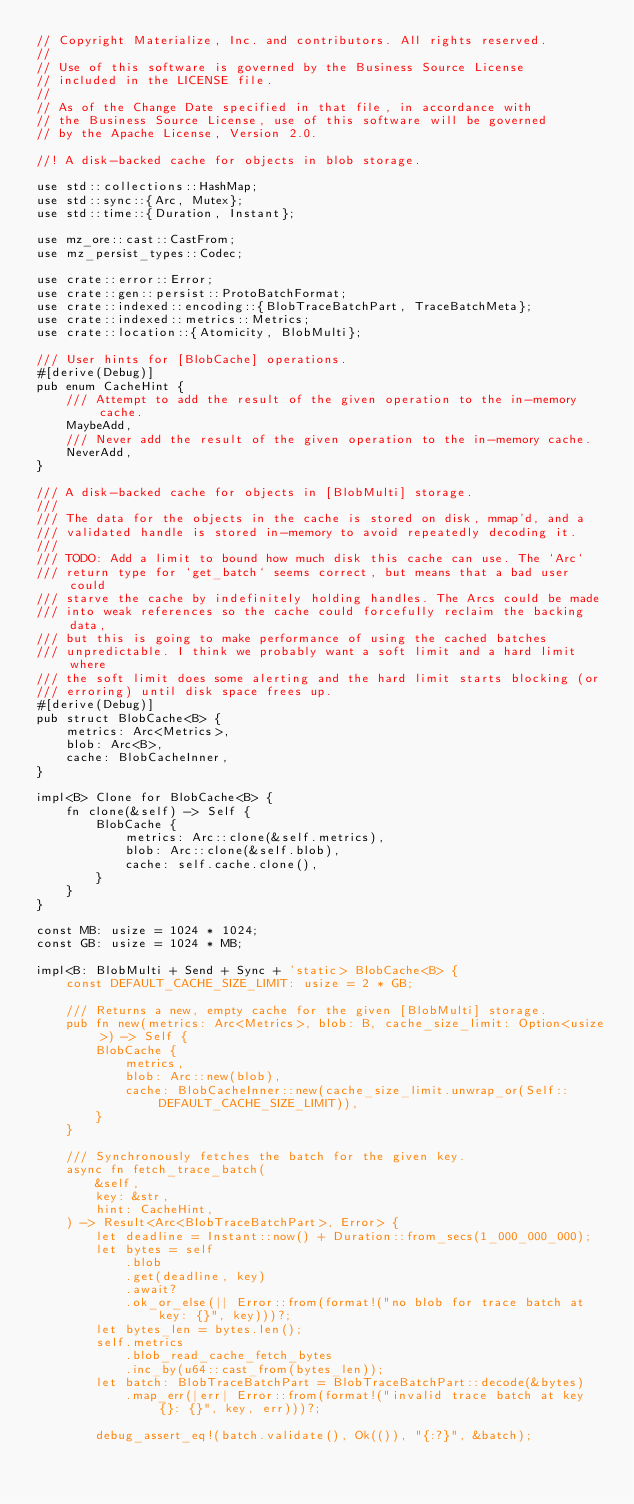Convert code to text. <code><loc_0><loc_0><loc_500><loc_500><_Rust_>// Copyright Materialize, Inc. and contributors. All rights reserved.
//
// Use of this software is governed by the Business Source License
// included in the LICENSE file.
//
// As of the Change Date specified in that file, in accordance with
// the Business Source License, use of this software will be governed
// by the Apache License, Version 2.0.

//! A disk-backed cache for objects in blob storage.

use std::collections::HashMap;
use std::sync::{Arc, Mutex};
use std::time::{Duration, Instant};

use mz_ore::cast::CastFrom;
use mz_persist_types::Codec;

use crate::error::Error;
use crate::gen::persist::ProtoBatchFormat;
use crate::indexed::encoding::{BlobTraceBatchPart, TraceBatchMeta};
use crate::indexed::metrics::Metrics;
use crate::location::{Atomicity, BlobMulti};

/// User hints for [BlobCache] operations.
#[derive(Debug)]
pub enum CacheHint {
    /// Attempt to add the result of the given operation to the in-memory cache.
    MaybeAdd,
    /// Never add the result of the given operation to the in-memory cache.
    NeverAdd,
}

/// A disk-backed cache for objects in [BlobMulti] storage.
///
/// The data for the objects in the cache is stored on disk, mmap'd, and a
/// validated handle is stored in-memory to avoid repeatedly decoding it.
///
/// TODO: Add a limit to bound how much disk this cache can use. The `Arc`
/// return type for `get_batch` seems correct, but means that a bad user could
/// starve the cache by indefinitely holding handles. The Arcs could be made
/// into weak references so the cache could forcefully reclaim the backing data,
/// but this is going to make performance of using the cached batches
/// unpredictable. I think we probably want a soft limit and a hard limit where
/// the soft limit does some alerting and the hard limit starts blocking (or
/// erroring) until disk space frees up.
#[derive(Debug)]
pub struct BlobCache<B> {
    metrics: Arc<Metrics>,
    blob: Arc<B>,
    cache: BlobCacheInner,
}

impl<B> Clone for BlobCache<B> {
    fn clone(&self) -> Self {
        BlobCache {
            metrics: Arc::clone(&self.metrics),
            blob: Arc::clone(&self.blob),
            cache: self.cache.clone(),
        }
    }
}

const MB: usize = 1024 * 1024;
const GB: usize = 1024 * MB;

impl<B: BlobMulti + Send + Sync + 'static> BlobCache<B> {
    const DEFAULT_CACHE_SIZE_LIMIT: usize = 2 * GB;

    /// Returns a new, empty cache for the given [BlobMulti] storage.
    pub fn new(metrics: Arc<Metrics>, blob: B, cache_size_limit: Option<usize>) -> Self {
        BlobCache {
            metrics,
            blob: Arc::new(blob),
            cache: BlobCacheInner::new(cache_size_limit.unwrap_or(Self::DEFAULT_CACHE_SIZE_LIMIT)),
        }
    }

    /// Synchronously fetches the batch for the given key.
    async fn fetch_trace_batch(
        &self,
        key: &str,
        hint: CacheHint,
    ) -> Result<Arc<BlobTraceBatchPart>, Error> {
        let deadline = Instant::now() + Duration::from_secs(1_000_000_000);
        let bytes = self
            .blob
            .get(deadline, key)
            .await?
            .ok_or_else(|| Error::from(format!("no blob for trace batch at key: {}", key)))?;
        let bytes_len = bytes.len();
        self.metrics
            .blob_read_cache_fetch_bytes
            .inc_by(u64::cast_from(bytes_len));
        let batch: BlobTraceBatchPart = BlobTraceBatchPart::decode(&bytes)
            .map_err(|err| Error::from(format!("invalid trace batch at key {}: {}", key, err)))?;

        debug_assert_eq!(batch.validate(), Ok(()), "{:?}", &batch);</code> 